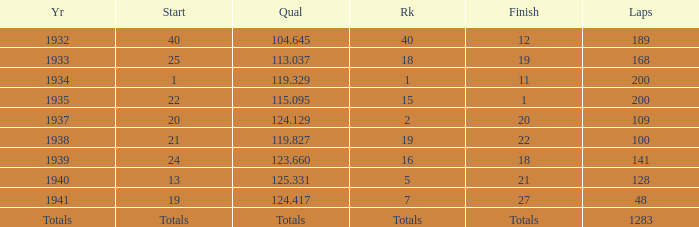What was the rank with the qual of 115.095? 15.0. 